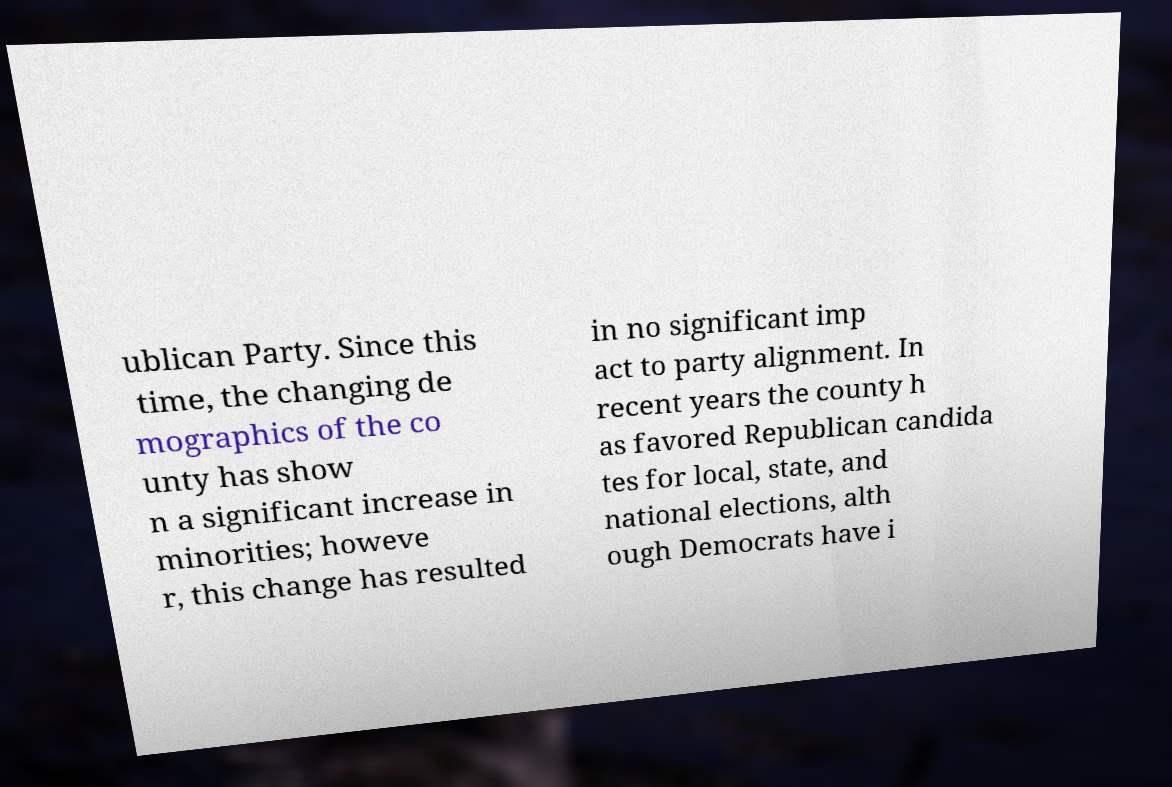There's text embedded in this image that I need extracted. Can you transcribe it verbatim? ublican Party. Since this time, the changing de mographics of the co unty has show n a significant increase in minorities; howeve r, this change has resulted in no significant imp act to party alignment. In recent years the county h as favored Republican candida tes for local, state, and national elections, alth ough Democrats have i 